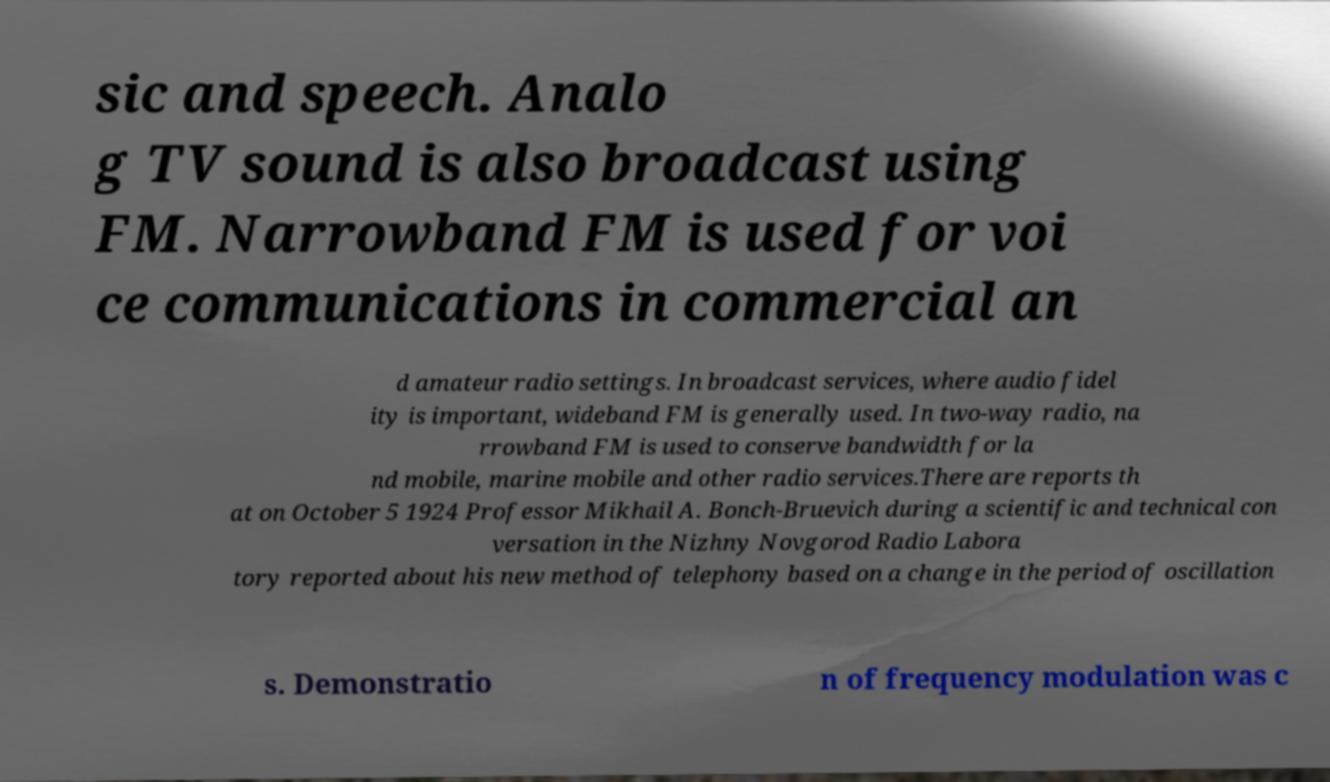Please read and relay the text visible in this image. What does it say? sic and speech. Analo g TV sound is also broadcast using FM. Narrowband FM is used for voi ce communications in commercial an d amateur radio settings. In broadcast services, where audio fidel ity is important, wideband FM is generally used. In two-way radio, na rrowband FM is used to conserve bandwidth for la nd mobile, marine mobile and other radio services.There are reports th at on October 5 1924 Professor Mikhail A. Bonch-Bruevich during a scientific and technical con versation in the Nizhny Novgorod Radio Labora tory reported about his new method of telephony based on a change in the period of oscillation s. Demonstratio n of frequency modulation was c 